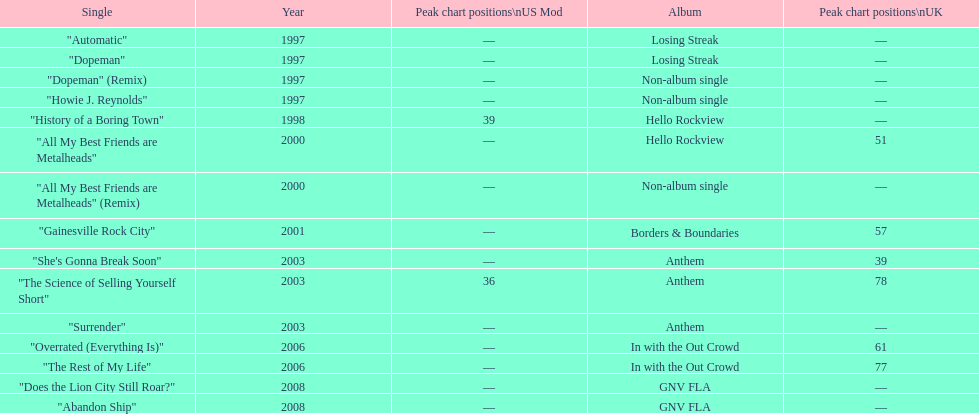What is an additional solo song featured on the "losing streak" album besides "dopeman"? "Automatic". 